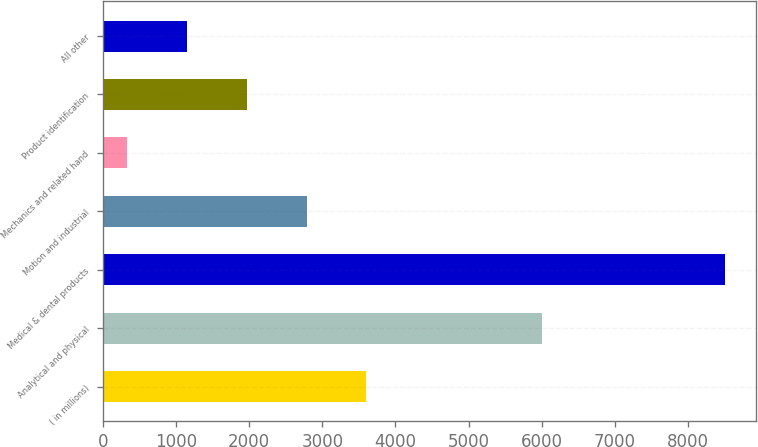<chart> <loc_0><loc_0><loc_500><loc_500><bar_chart><fcel>( in millions)<fcel>Analytical and physical<fcel>Medical & dental products<fcel>Motion and industrial<fcel>Mechanics and related hand<fcel>Product identification<fcel>All other<nl><fcel>3601.94<fcel>6000.8<fcel>8509.1<fcel>2784.08<fcel>330.5<fcel>1966.22<fcel>1148.36<nl></chart> 